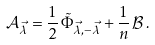Convert formula to latex. <formula><loc_0><loc_0><loc_500><loc_500>\mathcal { A } _ { \vec { \lambda } } = \frac { 1 } { 2 } \, \tilde { \Phi } _ { \vec { \lambda } , - \vec { \lambda } } + \frac { 1 } { n } \, \mathcal { B } \, .</formula> 